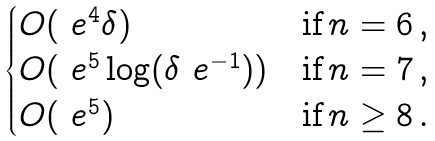<formula> <loc_0><loc_0><loc_500><loc_500>\begin{cases} O ( \ e ^ { 4 } \delta ) & \text {if} \, n = 6 \, , \\ O ( \ e ^ { 5 } \log ( \delta \ e ^ { - 1 } ) ) & \text {if} \, n = 7 \, , \\ O ( \ e ^ { 5 } ) & \text {if} \, n \geq 8 \, . \end{cases}</formula> 